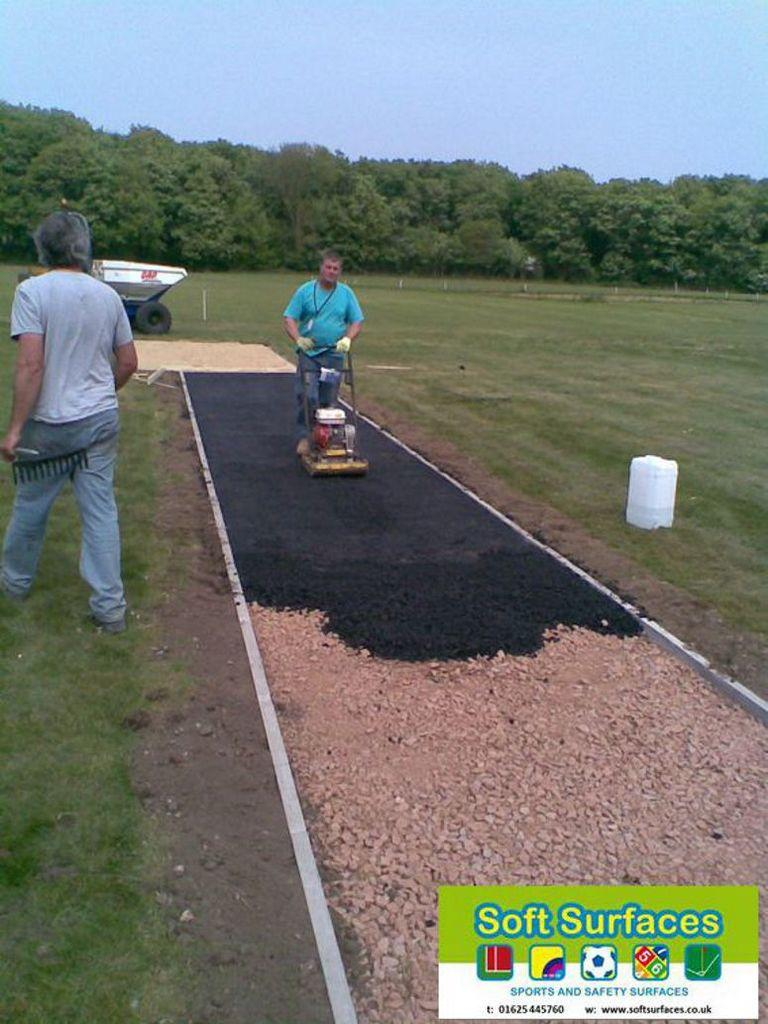Who is present in the image? There is a man in the image. What is the man holding in the image? The man is holding a machine in the image. What can be seen in the background of the image? There are trees in the background of the image. What is the condition of the sky in the image? The sky is clear in the image. Where is the logo located in the image? The logo is on the right bottom of the image. What type of produce is the grandmother growing in the image? There is no grandmother or produce present in the image. 